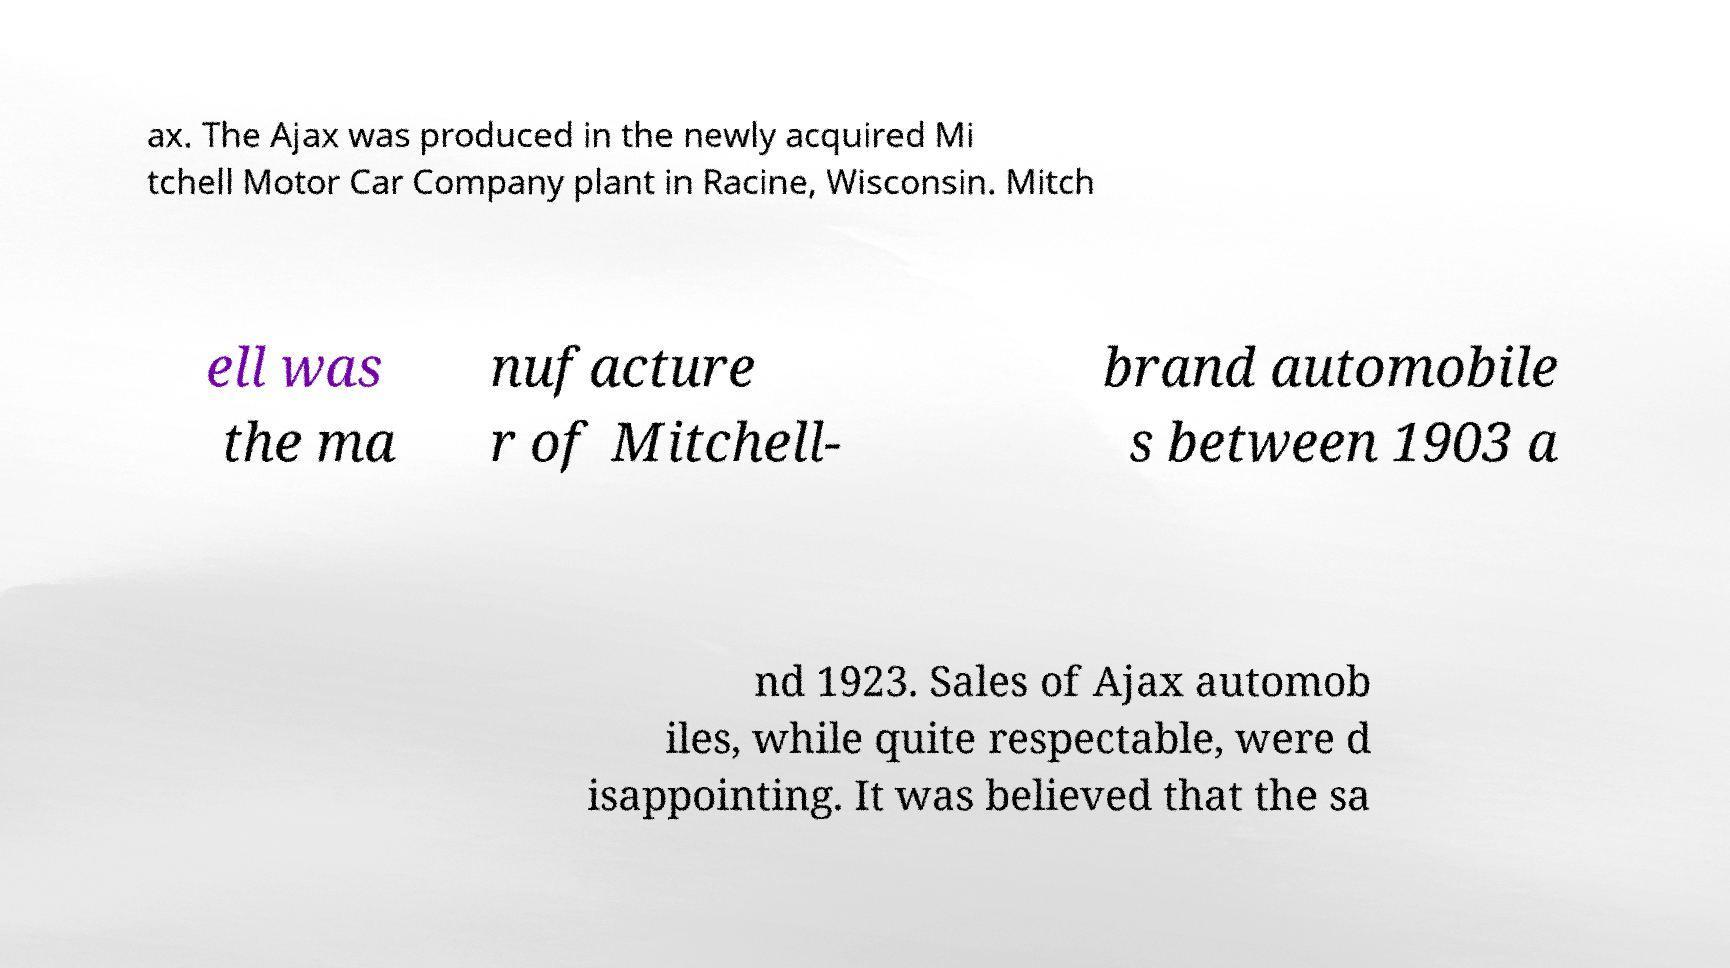Could you assist in decoding the text presented in this image and type it out clearly? ax. The Ajax was produced in the newly acquired Mi tchell Motor Car Company plant in Racine, Wisconsin. Mitch ell was the ma nufacture r of Mitchell- brand automobile s between 1903 a nd 1923. Sales of Ajax automob iles, while quite respectable, were d isappointing. It was believed that the sa 